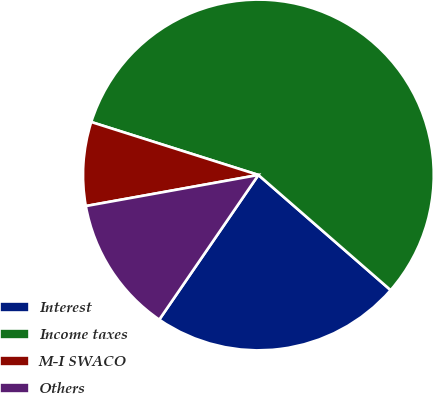Convert chart. <chart><loc_0><loc_0><loc_500><loc_500><pie_chart><fcel>Interest<fcel>Income taxes<fcel>M-I SWACO<fcel>Others<nl><fcel>23.16%<fcel>56.52%<fcel>7.72%<fcel>12.6%<nl></chart> 